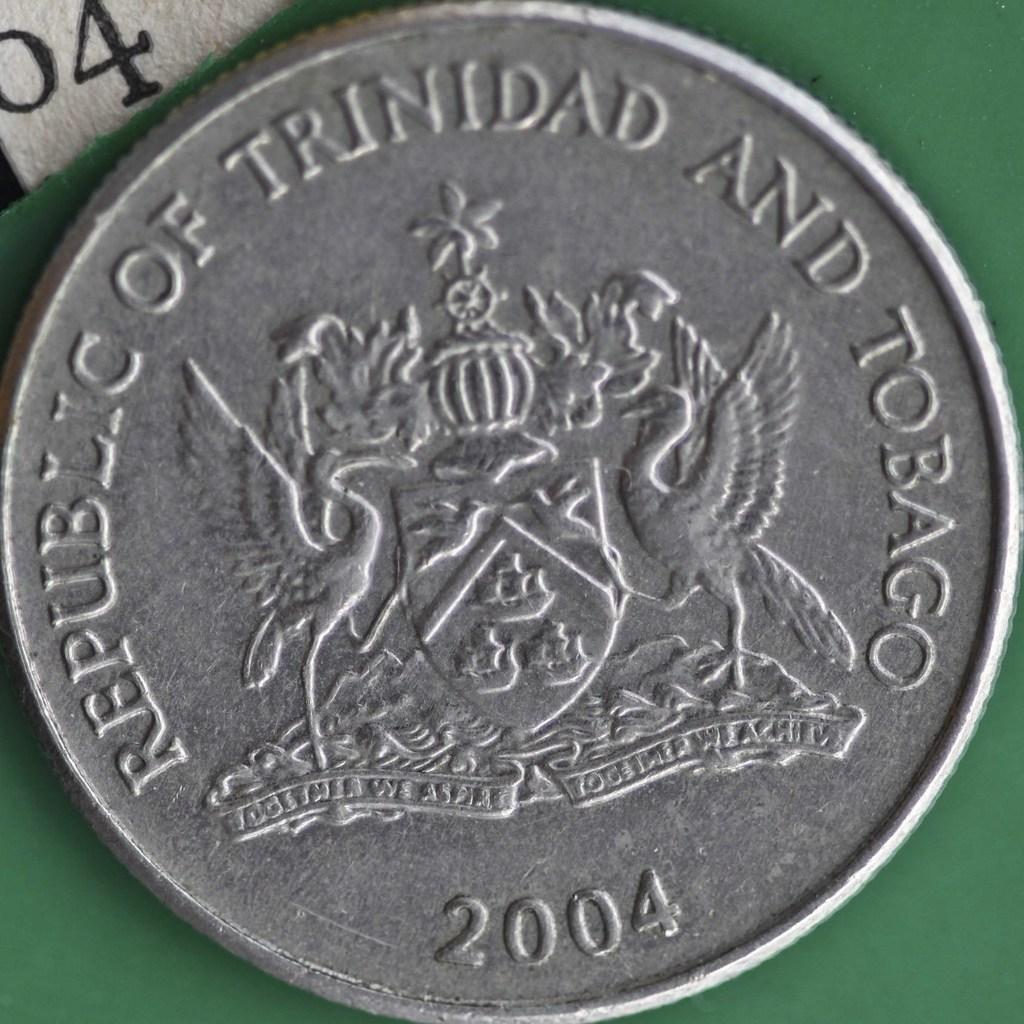<image>
Share a concise interpretation of the image provided. A round silver coin from the Republic of Trinidad and Tobago displays a coat of arms which reads, together we aspire, together we achieve. 